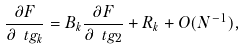Convert formula to latex. <formula><loc_0><loc_0><loc_500><loc_500>\frac { \partial F } { \partial \ t g _ { k } } = B _ { k } \frac { \partial F } { \partial \ t g _ { 2 } } + R _ { k } + O ( N ^ { - 1 } ) ,</formula> 